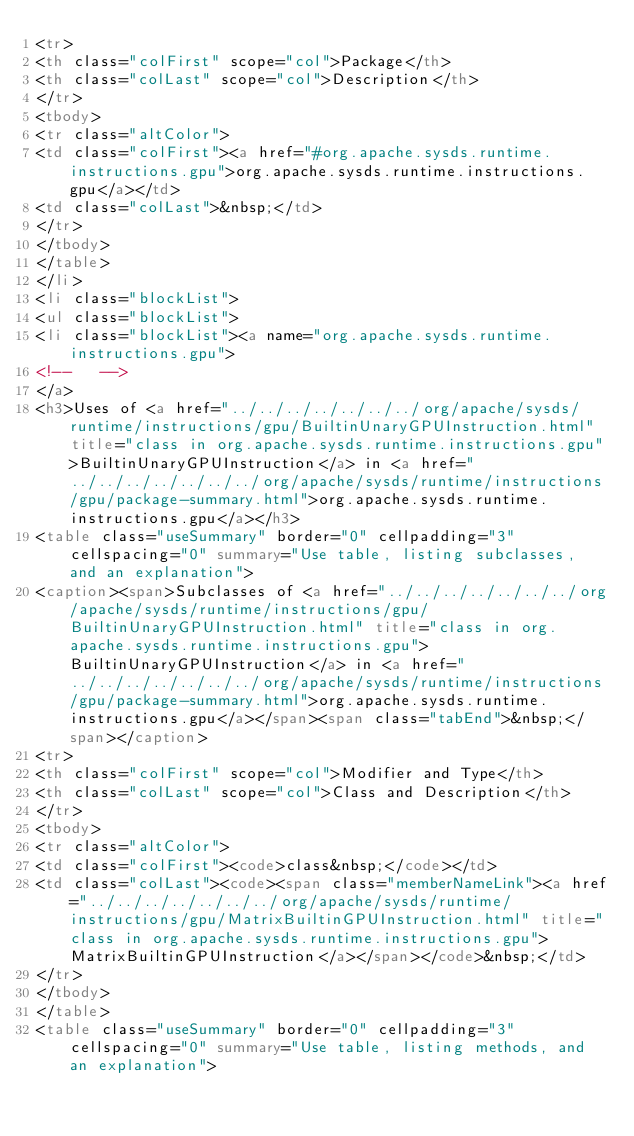Convert code to text. <code><loc_0><loc_0><loc_500><loc_500><_HTML_><tr>
<th class="colFirst" scope="col">Package</th>
<th class="colLast" scope="col">Description</th>
</tr>
<tbody>
<tr class="altColor">
<td class="colFirst"><a href="#org.apache.sysds.runtime.instructions.gpu">org.apache.sysds.runtime.instructions.gpu</a></td>
<td class="colLast">&nbsp;</td>
</tr>
</tbody>
</table>
</li>
<li class="blockList">
<ul class="blockList">
<li class="blockList"><a name="org.apache.sysds.runtime.instructions.gpu">
<!--   -->
</a>
<h3>Uses of <a href="../../../../../../../org/apache/sysds/runtime/instructions/gpu/BuiltinUnaryGPUInstruction.html" title="class in org.apache.sysds.runtime.instructions.gpu">BuiltinUnaryGPUInstruction</a> in <a href="../../../../../../../org/apache/sysds/runtime/instructions/gpu/package-summary.html">org.apache.sysds.runtime.instructions.gpu</a></h3>
<table class="useSummary" border="0" cellpadding="3" cellspacing="0" summary="Use table, listing subclasses, and an explanation">
<caption><span>Subclasses of <a href="../../../../../../../org/apache/sysds/runtime/instructions/gpu/BuiltinUnaryGPUInstruction.html" title="class in org.apache.sysds.runtime.instructions.gpu">BuiltinUnaryGPUInstruction</a> in <a href="../../../../../../../org/apache/sysds/runtime/instructions/gpu/package-summary.html">org.apache.sysds.runtime.instructions.gpu</a></span><span class="tabEnd">&nbsp;</span></caption>
<tr>
<th class="colFirst" scope="col">Modifier and Type</th>
<th class="colLast" scope="col">Class and Description</th>
</tr>
<tbody>
<tr class="altColor">
<td class="colFirst"><code>class&nbsp;</code></td>
<td class="colLast"><code><span class="memberNameLink"><a href="../../../../../../../org/apache/sysds/runtime/instructions/gpu/MatrixBuiltinGPUInstruction.html" title="class in org.apache.sysds.runtime.instructions.gpu">MatrixBuiltinGPUInstruction</a></span></code>&nbsp;</td>
</tr>
</tbody>
</table>
<table class="useSummary" border="0" cellpadding="3" cellspacing="0" summary="Use table, listing methods, and an explanation"></code> 